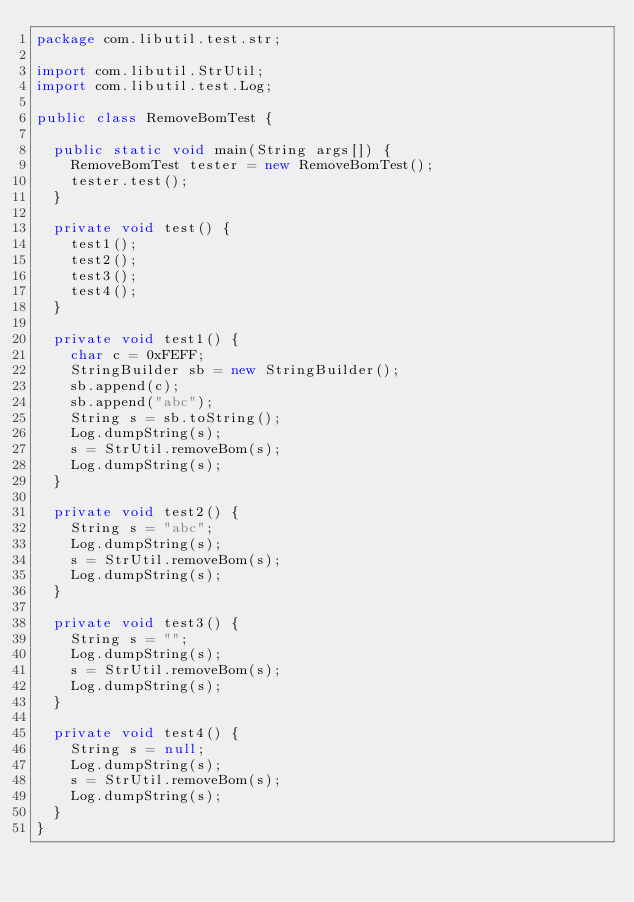<code> <loc_0><loc_0><loc_500><loc_500><_Java_>package com.libutil.test.str;

import com.libutil.StrUtil;
import com.libutil.test.Log;

public class RemoveBomTest {

  public static void main(String args[]) {
    RemoveBomTest tester = new RemoveBomTest();
    tester.test();
  }

  private void test() {
    test1();
    test2();
    test3();
    test4();
  }

  private void test1() {
    char c = 0xFEFF;
    StringBuilder sb = new StringBuilder();
    sb.append(c);
    sb.append("abc");
    String s = sb.toString();
    Log.dumpString(s);
    s = StrUtil.removeBom(s);
    Log.dumpString(s);
  }

  private void test2() {
    String s = "abc";
    Log.dumpString(s);
    s = StrUtil.removeBom(s);
    Log.dumpString(s);
  }

  private void test3() {
    String s = "";
    Log.dumpString(s);
    s = StrUtil.removeBom(s);
    Log.dumpString(s);
  }

  private void test4() {
    String s = null;
    Log.dumpString(s);
    s = StrUtil.removeBom(s);
    Log.dumpString(s);
  }
}
</code> 